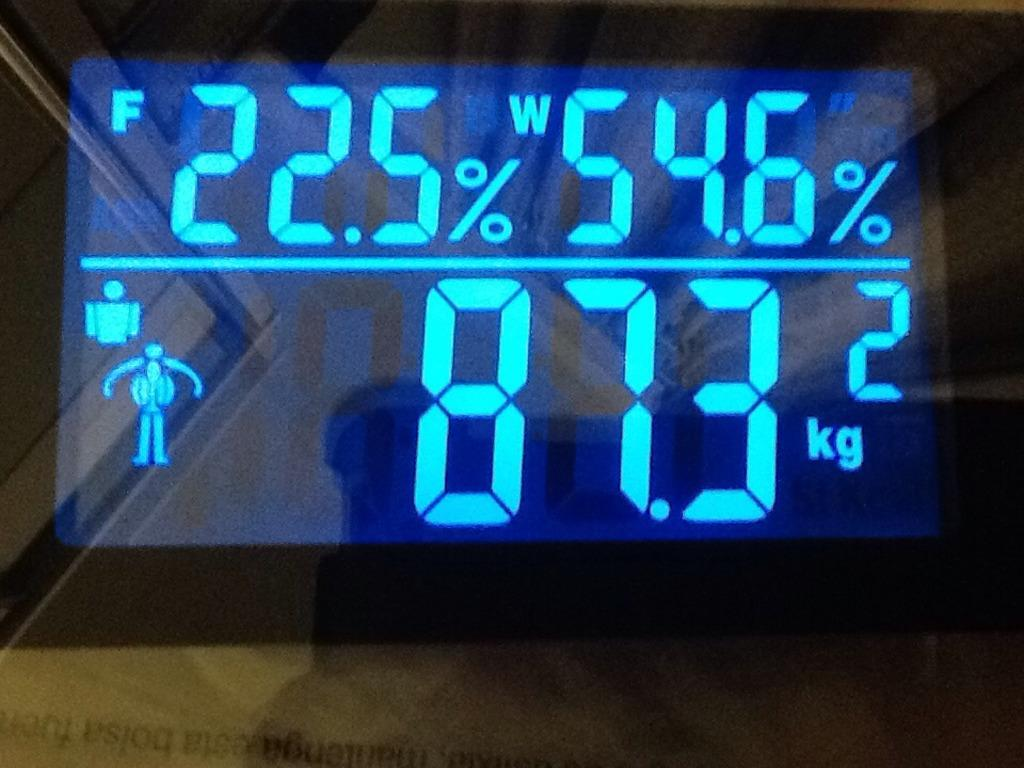<image>
Create a compact narrative representing the image presented. A digital weighing device is showing a reading of 87.3 kilograms on its face in blue lights. 